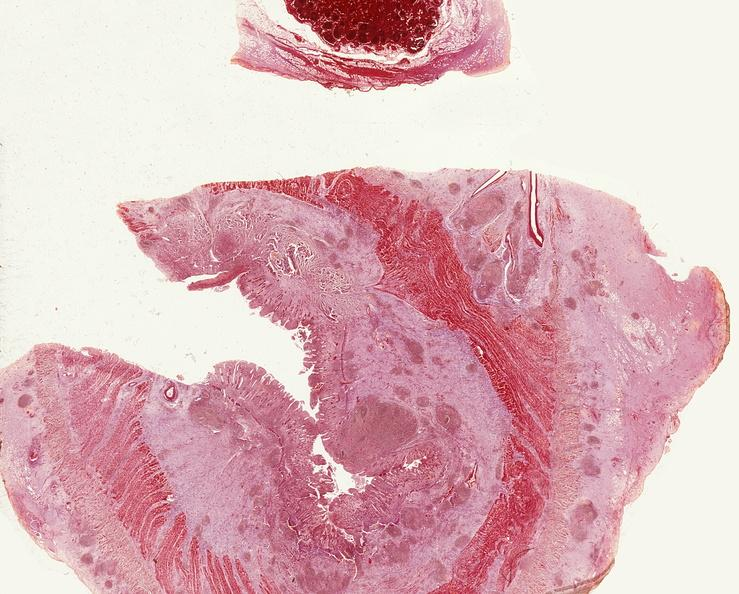what does this image show?
Answer the question using a single word or phrase. Small intestine 